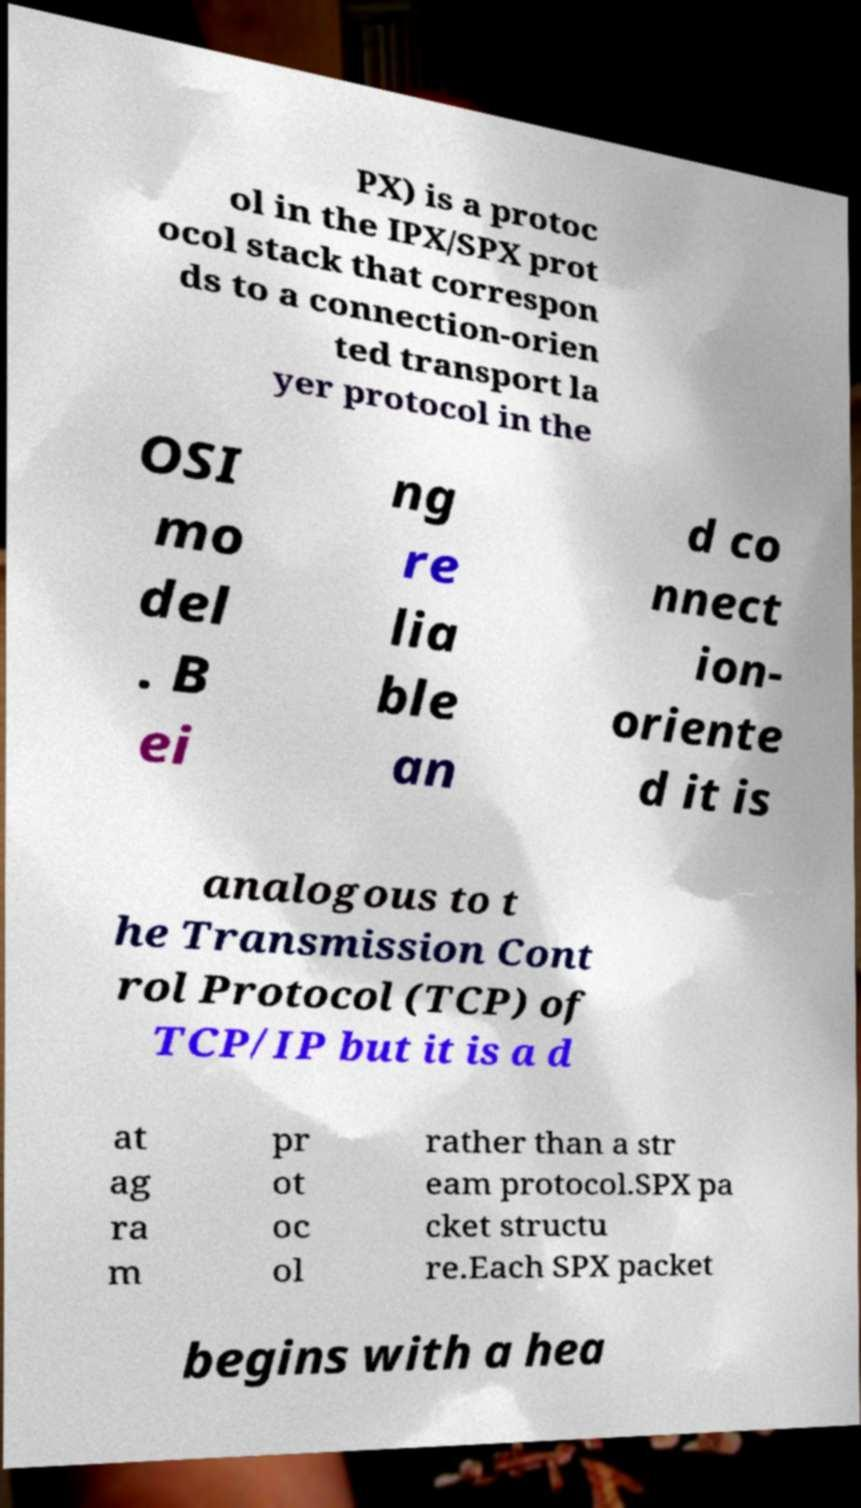I need the written content from this picture converted into text. Can you do that? PX) is a protoc ol in the IPX/SPX prot ocol stack that correspon ds to a connection-orien ted transport la yer protocol in the OSI mo del . B ei ng re lia ble an d co nnect ion- oriente d it is analogous to t he Transmission Cont rol Protocol (TCP) of TCP/IP but it is a d at ag ra m pr ot oc ol rather than a str eam protocol.SPX pa cket structu re.Each SPX packet begins with a hea 